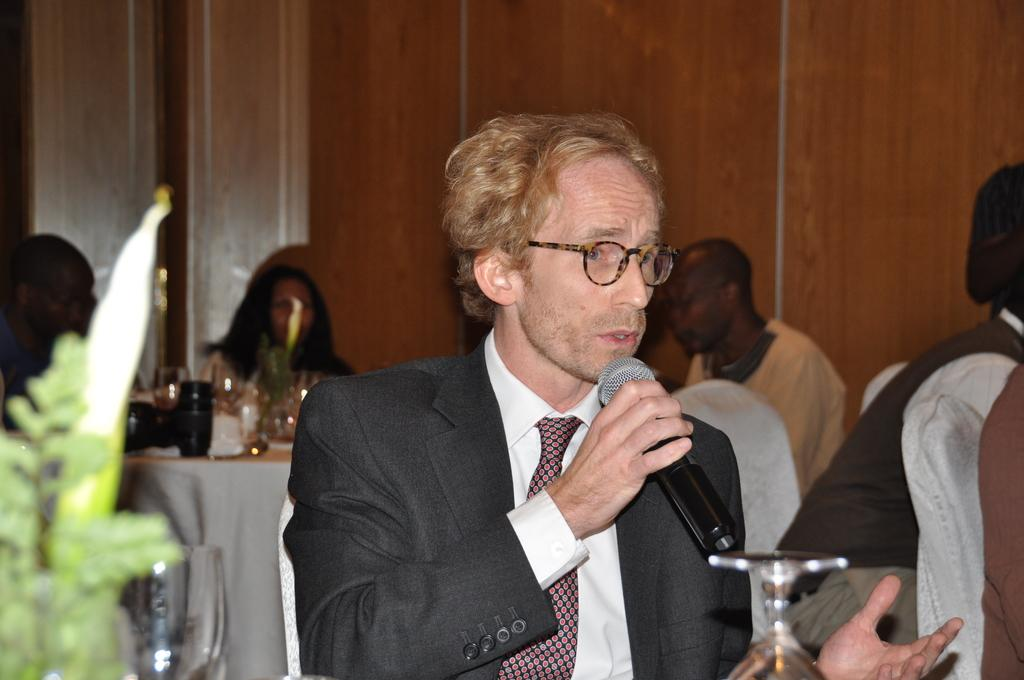What is the man in the image doing? The man is sitting in the image and holding a microphone. Are there any other people in the image? Yes, there are people sitting on chairs in the image. What is present in the image that might be used for holding objects? There is a table in the image. What is visible in the background of the image? There is a wall in the image. What type of smile can be seen on the sister's face in the image? There is no sister present in the image, and therefore no smile to observe. 